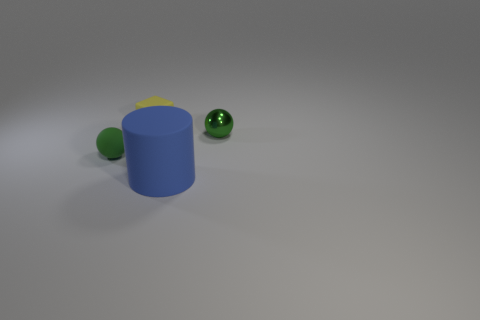How many metallic things are either tiny yellow objects or big yellow balls?
Your response must be concise. 0. Are there any large objects that have the same material as the small yellow cube?
Keep it short and to the point. Yes. What is the material of the tiny yellow cube?
Keep it short and to the point. Rubber. What shape is the green metallic thing that is to the right of the small matte object that is in front of the small sphere that is on the right side of the blue cylinder?
Offer a terse response. Sphere. Is the number of big cylinders behind the matte sphere greater than the number of green metallic objects?
Your answer should be very brief. No. Do the small green metal object and the tiny rubber object that is on the right side of the small green matte object have the same shape?
Provide a short and direct response. No. There is a thing that is the same color as the metal sphere; what is its shape?
Your response must be concise. Sphere. How many blue cylinders are to the left of the rubber thing that is behind the tiny rubber object in front of the small green metallic sphere?
Offer a very short reply. 0. What is the color of the cube that is the same size as the shiny object?
Ensure brevity in your answer.  Yellow. What size is the ball that is left of the green object to the right of the yellow block?
Your answer should be compact. Small. 